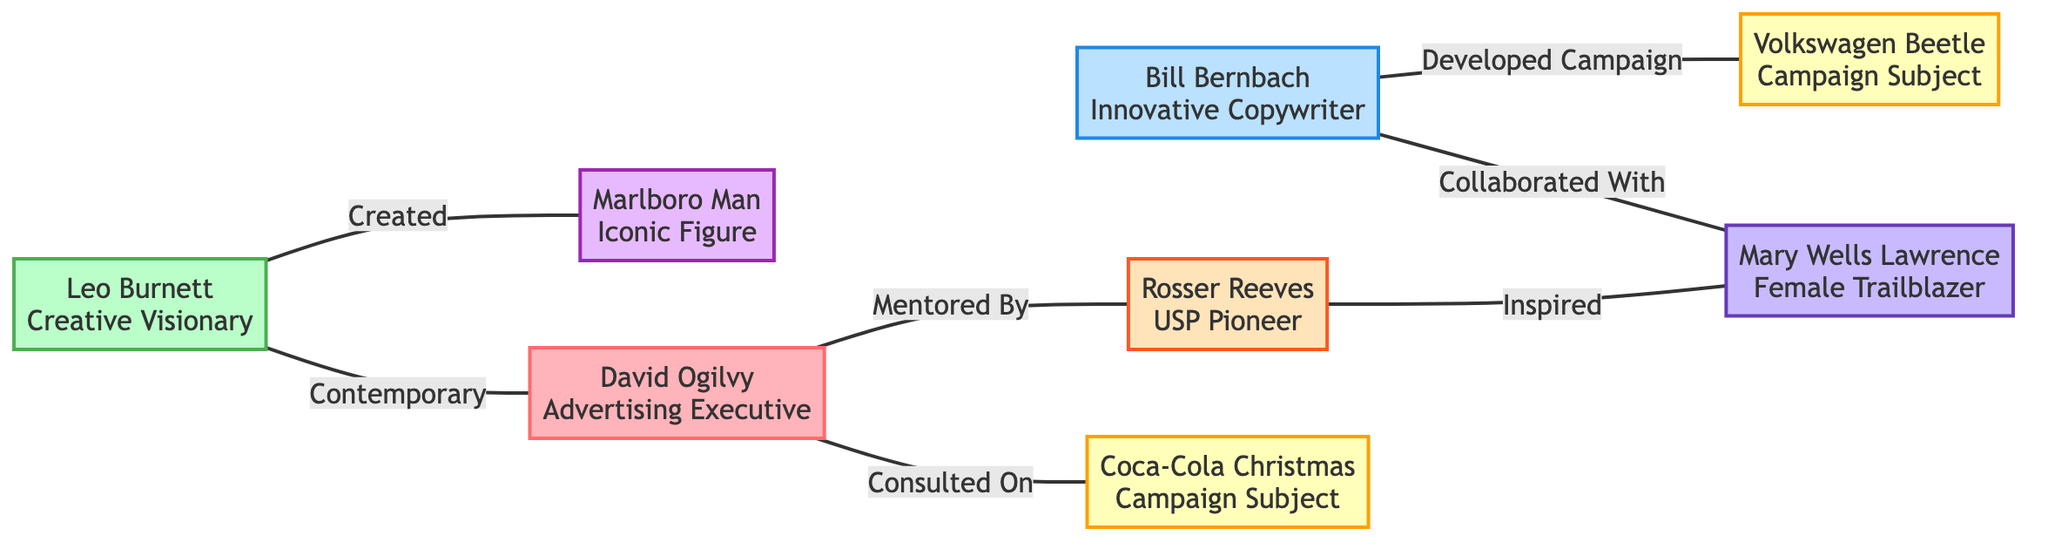What is the total number of nodes in the diagram? The diagram shows a list of 8 nodes: David Ogilvy, Leo Burnett, Bill Bernbach, Volkswagen Beetle, Marlboro Man, Coca-Cola Christmas, Rosser Reeves, and Mary Wells Lawrence. Counting them gives a total of 8 nodes.
Answer: 8 What relationship does David Ogilvy have with Rosser Reeves? The edge connecting David Ogilvy and Rosser Reeves is labeled "Mentored By," indicating that David Ogilvy was mentored by Rosser Reeves.
Answer: Mentored By Which key figure created the Marlboro Man? The diagram shows an edge from Leo Burnett to Marlboro Man labeled "Created," indicating that Leo Burnett is the key figure behind the Marlboro Man.
Answer: Leo Burnett How many edges are there in total? The diagram displays 7 edges connecting the various nodes. Each edge represents a relationship between the figures and campaign subjects, and counting them results in a total of 7 edges.
Answer: 7 Who is connected to both Bill Bernbach and Mary Wells Lawrence? The diagram has an edge from Bill Bernbach to Mary Wells Lawrence labeled "Collaborated With." Since there is no edge listed connecting them directly to another common key figure other than their connection to each other, the answer is Bill Bernbach.
Answer: Bill Bernbach What is the relationship of Rosser Reeves with Mary Wells Lawrence? The edge between Rosser Reeves and Mary Wells Lawrence is labeled "Inspired," indicating that Rosser Reeves inspired Mary Wells Lawrence in her work.
Answer: Inspired Which campaign subject is associated with David Ogilvy? According to the diagram, David Ogilvy is associated with Coca-Cola Christmas, as indicated by the edge labeled "Consulted On."
Answer: Coca-Cola Christmas Which two figures are contemporaries according to the diagram? The diagram shows an edge labeled "Contemporary" between Leo Burnett and David Ogilvy, illustrating that they are contemporaneous figures in the marketing field.
Answer: Leo Burnett, David Ogilvy 